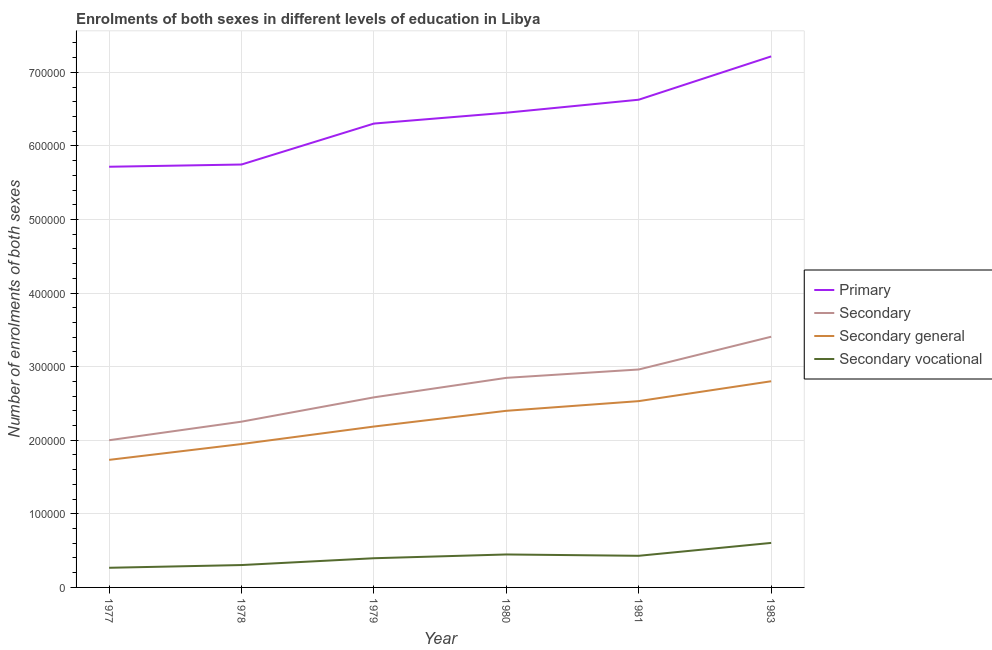Does the line corresponding to number of enrolments in secondary vocational education intersect with the line corresponding to number of enrolments in primary education?
Keep it short and to the point. No. What is the number of enrolments in primary education in 1978?
Provide a succinct answer. 5.75e+05. Across all years, what is the maximum number of enrolments in secondary vocational education?
Offer a terse response. 6.05e+04. Across all years, what is the minimum number of enrolments in primary education?
Provide a short and direct response. 5.72e+05. What is the total number of enrolments in secondary education in the graph?
Make the answer very short. 1.61e+06. What is the difference between the number of enrolments in secondary education in 1981 and that in 1983?
Give a very brief answer. -4.45e+04. What is the difference between the number of enrolments in secondary education in 1978 and the number of enrolments in primary education in 1977?
Provide a succinct answer. -3.46e+05. What is the average number of enrolments in secondary vocational education per year?
Your answer should be very brief. 4.08e+04. In the year 1977, what is the difference between the number of enrolments in secondary general education and number of enrolments in secondary vocational education?
Provide a short and direct response. 1.47e+05. What is the ratio of the number of enrolments in secondary vocational education in 1977 to that in 1981?
Your answer should be very brief. 0.62. What is the difference between the highest and the second highest number of enrolments in secondary general education?
Offer a very short reply. 2.70e+04. What is the difference between the highest and the lowest number of enrolments in secondary education?
Keep it short and to the point. 1.41e+05. Is the sum of the number of enrolments in secondary vocational education in 1978 and 1980 greater than the maximum number of enrolments in secondary general education across all years?
Provide a short and direct response. No. Does the number of enrolments in secondary general education monotonically increase over the years?
Offer a very short reply. Yes. Is the number of enrolments in secondary general education strictly greater than the number of enrolments in secondary education over the years?
Make the answer very short. No. Is the number of enrolments in secondary vocational education strictly less than the number of enrolments in secondary general education over the years?
Keep it short and to the point. Yes. How many lines are there?
Make the answer very short. 4. What is the difference between two consecutive major ticks on the Y-axis?
Your answer should be very brief. 1.00e+05. Does the graph contain grids?
Keep it short and to the point. Yes. Where does the legend appear in the graph?
Your answer should be compact. Center right. What is the title of the graph?
Offer a very short reply. Enrolments of both sexes in different levels of education in Libya. Does "Agriculture" appear as one of the legend labels in the graph?
Make the answer very short. No. What is the label or title of the Y-axis?
Make the answer very short. Number of enrolments of both sexes. What is the Number of enrolments of both sexes in Primary in 1977?
Give a very brief answer. 5.72e+05. What is the Number of enrolments of both sexes of Secondary in 1977?
Offer a terse response. 2.00e+05. What is the Number of enrolments of both sexes of Secondary general in 1977?
Your response must be concise. 1.73e+05. What is the Number of enrolments of both sexes of Secondary vocational in 1977?
Your answer should be very brief. 2.67e+04. What is the Number of enrolments of both sexes of Primary in 1978?
Your response must be concise. 5.75e+05. What is the Number of enrolments of both sexes of Secondary in 1978?
Your response must be concise. 2.25e+05. What is the Number of enrolments of both sexes of Secondary general in 1978?
Provide a succinct answer. 1.95e+05. What is the Number of enrolments of both sexes in Secondary vocational in 1978?
Your answer should be compact. 3.04e+04. What is the Number of enrolments of both sexes of Primary in 1979?
Your answer should be compact. 6.30e+05. What is the Number of enrolments of both sexes in Secondary in 1979?
Ensure brevity in your answer.  2.58e+05. What is the Number of enrolments of both sexes in Secondary general in 1979?
Give a very brief answer. 2.19e+05. What is the Number of enrolments of both sexes in Secondary vocational in 1979?
Offer a terse response. 3.97e+04. What is the Number of enrolments of both sexes in Primary in 1980?
Provide a short and direct response. 6.45e+05. What is the Number of enrolments of both sexes of Secondary in 1980?
Ensure brevity in your answer.  2.85e+05. What is the Number of enrolments of both sexes in Secondary general in 1980?
Provide a succinct answer. 2.40e+05. What is the Number of enrolments of both sexes in Secondary vocational in 1980?
Offer a very short reply. 4.48e+04. What is the Number of enrolments of both sexes in Primary in 1981?
Offer a very short reply. 6.63e+05. What is the Number of enrolments of both sexes in Secondary in 1981?
Offer a terse response. 2.96e+05. What is the Number of enrolments of both sexes in Secondary general in 1981?
Your answer should be compact. 2.53e+05. What is the Number of enrolments of both sexes in Secondary vocational in 1981?
Your answer should be compact. 4.30e+04. What is the Number of enrolments of both sexes of Primary in 1983?
Offer a very short reply. 7.22e+05. What is the Number of enrolments of both sexes in Secondary in 1983?
Your response must be concise. 3.41e+05. What is the Number of enrolments of both sexes in Secondary general in 1983?
Make the answer very short. 2.80e+05. What is the Number of enrolments of both sexes of Secondary vocational in 1983?
Ensure brevity in your answer.  6.05e+04. Across all years, what is the maximum Number of enrolments of both sexes of Primary?
Your answer should be compact. 7.22e+05. Across all years, what is the maximum Number of enrolments of both sexes in Secondary?
Keep it short and to the point. 3.41e+05. Across all years, what is the maximum Number of enrolments of both sexes of Secondary general?
Give a very brief answer. 2.80e+05. Across all years, what is the maximum Number of enrolments of both sexes in Secondary vocational?
Your answer should be very brief. 6.05e+04. Across all years, what is the minimum Number of enrolments of both sexes of Primary?
Keep it short and to the point. 5.72e+05. Across all years, what is the minimum Number of enrolments of both sexes in Secondary?
Your answer should be compact. 2.00e+05. Across all years, what is the minimum Number of enrolments of both sexes of Secondary general?
Keep it short and to the point. 1.73e+05. Across all years, what is the minimum Number of enrolments of both sexes in Secondary vocational?
Give a very brief answer. 2.67e+04. What is the total Number of enrolments of both sexes in Primary in the graph?
Offer a very short reply. 3.81e+06. What is the total Number of enrolments of both sexes of Secondary in the graph?
Your response must be concise. 1.61e+06. What is the total Number of enrolments of both sexes of Secondary general in the graph?
Offer a terse response. 1.36e+06. What is the total Number of enrolments of both sexes in Secondary vocational in the graph?
Offer a terse response. 2.45e+05. What is the difference between the Number of enrolments of both sexes of Primary in 1977 and that in 1978?
Make the answer very short. -3047. What is the difference between the Number of enrolments of both sexes in Secondary in 1977 and that in 1978?
Offer a very short reply. -2.52e+04. What is the difference between the Number of enrolments of both sexes of Secondary general in 1977 and that in 1978?
Ensure brevity in your answer.  -2.15e+04. What is the difference between the Number of enrolments of both sexes in Secondary vocational in 1977 and that in 1978?
Offer a terse response. -3711. What is the difference between the Number of enrolments of both sexes in Primary in 1977 and that in 1979?
Offer a terse response. -5.87e+04. What is the difference between the Number of enrolments of both sexes in Secondary in 1977 and that in 1979?
Keep it short and to the point. -5.83e+04. What is the difference between the Number of enrolments of both sexes of Secondary general in 1977 and that in 1979?
Provide a short and direct response. -4.53e+04. What is the difference between the Number of enrolments of both sexes of Secondary vocational in 1977 and that in 1979?
Offer a very short reply. -1.30e+04. What is the difference between the Number of enrolments of both sexes of Primary in 1977 and that in 1980?
Provide a succinct answer. -7.35e+04. What is the difference between the Number of enrolments of both sexes in Secondary in 1977 and that in 1980?
Provide a short and direct response. -8.48e+04. What is the difference between the Number of enrolments of both sexes in Secondary general in 1977 and that in 1980?
Your response must be concise. -6.67e+04. What is the difference between the Number of enrolments of both sexes of Secondary vocational in 1977 and that in 1980?
Your response must be concise. -1.81e+04. What is the difference between the Number of enrolments of both sexes in Primary in 1977 and that in 1981?
Give a very brief answer. -9.11e+04. What is the difference between the Number of enrolments of both sexes of Secondary in 1977 and that in 1981?
Give a very brief answer. -9.61e+04. What is the difference between the Number of enrolments of both sexes of Secondary general in 1977 and that in 1981?
Your answer should be compact. -7.98e+04. What is the difference between the Number of enrolments of both sexes in Secondary vocational in 1977 and that in 1981?
Keep it short and to the point. -1.63e+04. What is the difference between the Number of enrolments of both sexes of Primary in 1977 and that in 1983?
Keep it short and to the point. -1.50e+05. What is the difference between the Number of enrolments of both sexes of Secondary in 1977 and that in 1983?
Your answer should be compact. -1.41e+05. What is the difference between the Number of enrolments of both sexes in Secondary general in 1977 and that in 1983?
Offer a very short reply. -1.07e+05. What is the difference between the Number of enrolments of both sexes in Secondary vocational in 1977 and that in 1983?
Make the answer very short. -3.38e+04. What is the difference between the Number of enrolments of both sexes in Primary in 1978 and that in 1979?
Give a very brief answer. -5.57e+04. What is the difference between the Number of enrolments of both sexes in Secondary in 1978 and that in 1979?
Offer a very short reply. -3.31e+04. What is the difference between the Number of enrolments of both sexes of Secondary general in 1978 and that in 1979?
Offer a very short reply. -2.38e+04. What is the difference between the Number of enrolments of both sexes in Secondary vocational in 1978 and that in 1979?
Ensure brevity in your answer.  -9257. What is the difference between the Number of enrolments of both sexes in Primary in 1978 and that in 1980?
Your answer should be very brief. -7.04e+04. What is the difference between the Number of enrolments of both sexes of Secondary in 1978 and that in 1980?
Ensure brevity in your answer.  -5.95e+04. What is the difference between the Number of enrolments of both sexes in Secondary general in 1978 and that in 1980?
Your answer should be very brief. -4.52e+04. What is the difference between the Number of enrolments of both sexes in Secondary vocational in 1978 and that in 1980?
Make the answer very short. -1.44e+04. What is the difference between the Number of enrolments of both sexes of Primary in 1978 and that in 1981?
Give a very brief answer. -8.81e+04. What is the difference between the Number of enrolments of both sexes in Secondary in 1978 and that in 1981?
Your response must be concise. -7.09e+04. What is the difference between the Number of enrolments of both sexes in Secondary general in 1978 and that in 1981?
Give a very brief answer. -5.83e+04. What is the difference between the Number of enrolments of both sexes in Secondary vocational in 1978 and that in 1981?
Your response must be concise. -1.26e+04. What is the difference between the Number of enrolments of both sexes of Primary in 1978 and that in 1983?
Your answer should be very brief. -1.47e+05. What is the difference between the Number of enrolments of both sexes of Secondary in 1978 and that in 1983?
Your response must be concise. -1.15e+05. What is the difference between the Number of enrolments of both sexes of Secondary general in 1978 and that in 1983?
Give a very brief answer. -8.53e+04. What is the difference between the Number of enrolments of both sexes in Secondary vocational in 1978 and that in 1983?
Your answer should be very brief. -3.01e+04. What is the difference between the Number of enrolments of both sexes in Primary in 1979 and that in 1980?
Ensure brevity in your answer.  -1.48e+04. What is the difference between the Number of enrolments of both sexes in Secondary in 1979 and that in 1980?
Ensure brevity in your answer.  -2.65e+04. What is the difference between the Number of enrolments of both sexes of Secondary general in 1979 and that in 1980?
Make the answer very short. -2.14e+04. What is the difference between the Number of enrolments of both sexes of Secondary vocational in 1979 and that in 1980?
Make the answer very short. -5113. What is the difference between the Number of enrolments of both sexes in Primary in 1979 and that in 1981?
Provide a short and direct response. -3.24e+04. What is the difference between the Number of enrolments of both sexes in Secondary in 1979 and that in 1981?
Offer a terse response. -3.79e+04. What is the difference between the Number of enrolments of both sexes of Secondary general in 1979 and that in 1981?
Provide a succinct answer. -3.45e+04. What is the difference between the Number of enrolments of both sexes of Secondary vocational in 1979 and that in 1981?
Your response must be concise. -3319. What is the difference between the Number of enrolments of both sexes of Primary in 1979 and that in 1983?
Keep it short and to the point. -9.13e+04. What is the difference between the Number of enrolments of both sexes in Secondary in 1979 and that in 1983?
Ensure brevity in your answer.  -8.24e+04. What is the difference between the Number of enrolments of both sexes in Secondary general in 1979 and that in 1983?
Ensure brevity in your answer.  -6.15e+04. What is the difference between the Number of enrolments of both sexes of Secondary vocational in 1979 and that in 1983?
Your answer should be compact. -2.08e+04. What is the difference between the Number of enrolments of both sexes in Primary in 1980 and that in 1981?
Provide a short and direct response. -1.77e+04. What is the difference between the Number of enrolments of both sexes in Secondary in 1980 and that in 1981?
Keep it short and to the point. -1.14e+04. What is the difference between the Number of enrolments of both sexes in Secondary general in 1980 and that in 1981?
Your answer should be very brief. -1.32e+04. What is the difference between the Number of enrolments of both sexes of Secondary vocational in 1980 and that in 1981?
Offer a very short reply. 1794. What is the difference between the Number of enrolments of both sexes of Primary in 1980 and that in 1983?
Your answer should be very brief. -7.65e+04. What is the difference between the Number of enrolments of both sexes of Secondary in 1980 and that in 1983?
Provide a short and direct response. -5.59e+04. What is the difference between the Number of enrolments of both sexes of Secondary general in 1980 and that in 1983?
Offer a terse response. -4.02e+04. What is the difference between the Number of enrolments of both sexes of Secondary vocational in 1980 and that in 1983?
Provide a succinct answer. -1.57e+04. What is the difference between the Number of enrolments of both sexes of Primary in 1981 and that in 1983?
Ensure brevity in your answer.  -5.89e+04. What is the difference between the Number of enrolments of both sexes in Secondary in 1981 and that in 1983?
Provide a succinct answer. -4.45e+04. What is the difference between the Number of enrolments of both sexes of Secondary general in 1981 and that in 1983?
Ensure brevity in your answer.  -2.70e+04. What is the difference between the Number of enrolments of both sexes of Secondary vocational in 1981 and that in 1983?
Your answer should be very brief. -1.75e+04. What is the difference between the Number of enrolments of both sexes of Primary in 1977 and the Number of enrolments of both sexes of Secondary in 1978?
Ensure brevity in your answer.  3.46e+05. What is the difference between the Number of enrolments of both sexes of Primary in 1977 and the Number of enrolments of both sexes of Secondary general in 1978?
Your answer should be very brief. 3.77e+05. What is the difference between the Number of enrolments of both sexes in Primary in 1977 and the Number of enrolments of both sexes in Secondary vocational in 1978?
Offer a terse response. 5.41e+05. What is the difference between the Number of enrolments of both sexes of Secondary in 1977 and the Number of enrolments of both sexes of Secondary general in 1978?
Your response must be concise. 5197. What is the difference between the Number of enrolments of both sexes of Secondary in 1977 and the Number of enrolments of both sexes of Secondary vocational in 1978?
Make the answer very short. 1.70e+05. What is the difference between the Number of enrolments of both sexes of Secondary general in 1977 and the Number of enrolments of both sexes of Secondary vocational in 1978?
Provide a succinct answer. 1.43e+05. What is the difference between the Number of enrolments of both sexes of Primary in 1977 and the Number of enrolments of both sexes of Secondary in 1979?
Offer a terse response. 3.13e+05. What is the difference between the Number of enrolments of both sexes in Primary in 1977 and the Number of enrolments of both sexes in Secondary general in 1979?
Your answer should be very brief. 3.53e+05. What is the difference between the Number of enrolments of both sexes in Primary in 1977 and the Number of enrolments of both sexes in Secondary vocational in 1979?
Provide a short and direct response. 5.32e+05. What is the difference between the Number of enrolments of both sexes in Secondary in 1977 and the Number of enrolments of both sexes in Secondary general in 1979?
Your answer should be very brief. -1.86e+04. What is the difference between the Number of enrolments of both sexes of Secondary in 1977 and the Number of enrolments of both sexes of Secondary vocational in 1979?
Your answer should be very brief. 1.60e+05. What is the difference between the Number of enrolments of both sexes in Secondary general in 1977 and the Number of enrolments of both sexes in Secondary vocational in 1979?
Make the answer very short. 1.34e+05. What is the difference between the Number of enrolments of both sexes in Primary in 1977 and the Number of enrolments of both sexes in Secondary in 1980?
Ensure brevity in your answer.  2.87e+05. What is the difference between the Number of enrolments of both sexes in Primary in 1977 and the Number of enrolments of both sexes in Secondary general in 1980?
Your answer should be very brief. 3.32e+05. What is the difference between the Number of enrolments of both sexes in Primary in 1977 and the Number of enrolments of both sexes in Secondary vocational in 1980?
Make the answer very short. 5.27e+05. What is the difference between the Number of enrolments of both sexes in Secondary in 1977 and the Number of enrolments of both sexes in Secondary general in 1980?
Make the answer very short. -4.00e+04. What is the difference between the Number of enrolments of both sexes in Secondary in 1977 and the Number of enrolments of both sexes in Secondary vocational in 1980?
Your answer should be compact. 1.55e+05. What is the difference between the Number of enrolments of both sexes of Secondary general in 1977 and the Number of enrolments of both sexes of Secondary vocational in 1980?
Ensure brevity in your answer.  1.29e+05. What is the difference between the Number of enrolments of both sexes in Primary in 1977 and the Number of enrolments of both sexes in Secondary in 1981?
Ensure brevity in your answer.  2.76e+05. What is the difference between the Number of enrolments of both sexes in Primary in 1977 and the Number of enrolments of both sexes in Secondary general in 1981?
Make the answer very short. 3.19e+05. What is the difference between the Number of enrolments of both sexes of Primary in 1977 and the Number of enrolments of both sexes of Secondary vocational in 1981?
Your answer should be very brief. 5.29e+05. What is the difference between the Number of enrolments of both sexes in Secondary in 1977 and the Number of enrolments of both sexes in Secondary general in 1981?
Your answer should be compact. -5.31e+04. What is the difference between the Number of enrolments of both sexes of Secondary in 1977 and the Number of enrolments of both sexes of Secondary vocational in 1981?
Your response must be concise. 1.57e+05. What is the difference between the Number of enrolments of both sexes in Secondary general in 1977 and the Number of enrolments of both sexes in Secondary vocational in 1981?
Your response must be concise. 1.30e+05. What is the difference between the Number of enrolments of both sexes of Primary in 1977 and the Number of enrolments of both sexes of Secondary in 1983?
Keep it short and to the point. 2.31e+05. What is the difference between the Number of enrolments of both sexes of Primary in 1977 and the Number of enrolments of both sexes of Secondary general in 1983?
Provide a succinct answer. 2.92e+05. What is the difference between the Number of enrolments of both sexes of Primary in 1977 and the Number of enrolments of both sexes of Secondary vocational in 1983?
Keep it short and to the point. 5.11e+05. What is the difference between the Number of enrolments of both sexes in Secondary in 1977 and the Number of enrolments of both sexes in Secondary general in 1983?
Your answer should be compact. -8.01e+04. What is the difference between the Number of enrolments of both sexes of Secondary in 1977 and the Number of enrolments of both sexes of Secondary vocational in 1983?
Offer a terse response. 1.40e+05. What is the difference between the Number of enrolments of both sexes of Secondary general in 1977 and the Number of enrolments of both sexes of Secondary vocational in 1983?
Your answer should be compact. 1.13e+05. What is the difference between the Number of enrolments of both sexes in Primary in 1978 and the Number of enrolments of both sexes in Secondary in 1979?
Ensure brevity in your answer.  3.16e+05. What is the difference between the Number of enrolments of both sexes of Primary in 1978 and the Number of enrolments of both sexes of Secondary general in 1979?
Give a very brief answer. 3.56e+05. What is the difference between the Number of enrolments of both sexes in Primary in 1978 and the Number of enrolments of both sexes in Secondary vocational in 1979?
Your response must be concise. 5.35e+05. What is the difference between the Number of enrolments of both sexes in Secondary in 1978 and the Number of enrolments of both sexes in Secondary general in 1979?
Your answer should be compact. 6620. What is the difference between the Number of enrolments of both sexes in Secondary in 1978 and the Number of enrolments of both sexes in Secondary vocational in 1979?
Offer a very short reply. 1.86e+05. What is the difference between the Number of enrolments of both sexes in Secondary general in 1978 and the Number of enrolments of both sexes in Secondary vocational in 1979?
Your response must be concise. 1.55e+05. What is the difference between the Number of enrolments of both sexes in Primary in 1978 and the Number of enrolments of both sexes in Secondary in 1980?
Your answer should be very brief. 2.90e+05. What is the difference between the Number of enrolments of both sexes of Primary in 1978 and the Number of enrolments of both sexes of Secondary general in 1980?
Offer a terse response. 3.35e+05. What is the difference between the Number of enrolments of both sexes in Primary in 1978 and the Number of enrolments of both sexes in Secondary vocational in 1980?
Give a very brief answer. 5.30e+05. What is the difference between the Number of enrolments of both sexes in Secondary in 1978 and the Number of enrolments of both sexes in Secondary general in 1980?
Provide a short and direct response. -1.48e+04. What is the difference between the Number of enrolments of both sexes in Secondary in 1978 and the Number of enrolments of both sexes in Secondary vocational in 1980?
Give a very brief answer. 1.80e+05. What is the difference between the Number of enrolments of both sexes of Secondary general in 1978 and the Number of enrolments of both sexes of Secondary vocational in 1980?
Offer a terse response. 1.50e+05. What is the difference between the Number of enrolments of both sexes in Primary in 1978 and the Number of enrolments of both sexes in Secondary in 1981?
Make the answer very short. 2.79e+05. What is the difference between the Number of enrolments of both sexes of Primary in 1978 and the Number of enrolments of both sexes of Secondary general in 1981?
Give a very brief answer. 3.22e+05. What is the difference between the Number of enrolments of both sexes of Primary in 1978 and the Number of enrolments of both sexes of Secondary vocational in 1981?
Provide a succinct answer. 5.32e+05. What is the difference between the Number of enrolments of both sexes in Secondary in 1978 and the Number of enrolments of both sexes in Secondary general in 1981?
Ensure brevity in your answer.  -2.79e+04. What is the difference between the Number of enrolments of both sexes of Secondary in 1978 and the Number of enrolments of both sexes of Secondary vocational in 1981?
Keep it short and to the point. 1.82e+05. What is the difference between the Number of enrolments of both sexes in Secondary general in 1978 and the Number of enrolments of both sexes in Secondary vocational in 1981?
Keep it short and to the point. 1.52e+05. What is the difference between the Number of enrolments of both sexes of Primary in 1978 and the Number of enrolments of both sexes of Secondary in 1983?
Your answer should be very brief. 2.34e+05. What is the difference between the Number of enrolments of both sexes of Primary in 1978 and the Number of enrolments of both sexes of Secondary general in 1983?
Keep it short and to the point. 2.95e+05. What is the difference between the Number of enrolments of both sexes in Primary in 1978 and the Number of enrolments of both sexes in Secondary vocational in 1983?
Ensure brevity in your answer.  5.14e+05. What is the difference between the Number of enrolments of both sexes in Secondary in 1978 and the Number of enrolments of both sexes in Secondary general in 1983?
Offer a terse response. -5.49e+04. What is the difference between the Number of enrolments of both sexes in Secondary in 1978 and the Number of enrolments of both sexes in Secondary vocational in 1983?
Provide a short and direct response. 1.65e+05. What is the difference between the Number of enrolments of both sexes in Secondary general in 1978 and the Number of enrolments of both sexes in Secondary vocational in 1983?
Your response must be concise. 1.34e+05. What is the difference between the Number of enrolments of both sexes in Primary in 1979 and the Number of enrolments of both sexes in Secondary in 1980?
Make the answer very short. 3.46e+05. What is the difference between the Number of enrolments of both sexes of Primary in 1979 and the Number of enrolments of both sexes of Secondary general in 1980?
Provide a succinct answer. 3.90e+05. What is the difference between the Number of enrolments of both sexes of Primary in 1979 and the Number of enrolments of both sexes of Secondary vocational in 1980?
Ensure brevity in your answer.  5.86e+05. What is the difference between the Number of enrolments of both sexes in Secondary in 1979 and the Number of enrolments of both sexes in Secondary general in 1980?
Your answer should be compact. 1.83e+04. What is the difference between the Number of enrolments of both sexes of Secondary in 1979 and the Number of enrolments of both sexes of Secondary vocational in 1980?
Provide a succinct answer. 2.14e+05. What is the difference between the Number of enrolments of both sexes of Secondary general in 1979 and the Number of enrolments of both sexes of Secondary vocational in 1980?
Offer a very short reply. 1.74e+05. What is the difference between the Number of enrolments of both sexes of Primary in 1979 and the Number of enrolments of both sexes of Secondary in 1981?
Provide a short and direct response. 3.34e+05. What is the difference between the Number of enrolments of both sexes in Primary in 1979 and the Number of enrolments of both sexes in Secondary general in 1981?
Offer a terse response. 3.77e+05. What is the difference between the Number of enrolments of both sexes of Primary in 1979 and the Number of enrolments of both sexes of Secondary vocational in 1981?
Keep it short and to the point. 5.87e+05. What is the difference between the Number of enrolments of both sexes in Secondary in 1979 and the Number of enrolments of both sexes in Secondary general in 1981?
Give a very brief answer. 5142. What is the difference between the Number of enrolments of both sexes in Secondary in 1979 and the Number of enrolments of both sexes in Secondary vocational in 1981?
Ensure brevity in your answer.  2.15e+05. What is the difference between the Number of enrolments of both sexes in Secondary general in 1979 and the Number of enrolments of both sexes in Secondary vocational in 1981?
Offer a terse response. 1.76e+05. What is the difference between the Number of enrolments of both sexes in Primary in 1979 and the Number of enrolments of both sexes in Secondary in 1983?
Provide a succinct answer. 2.90e+05. What is the difference between the Number of enrolments of both sexes in Primary in 1979 and the Number of enrolments of both sexes in Secondary general in 1983?
Keep it short and to the point. 3.50e+05. What is the difference between the Number of enrolments of both sexes in Primary in 1979 and the Number of enrolments of both sexes in Secondary vocational in 1983?
Provide a short and direct response. 5.70e+05. What is the difference between the Number of enrolments of both sexes in Secondary in 1979 and the Number of enrolments of both sexes in Secondary general in 1983?
Give a very brief answer. -2.19e+04. What is the difference between the Number of enrolments of both sexes of Secondary in 1979 and the Number of enrolments of both sexes of Secondary vocational in 1983?
Make the answer very short. 1.98e+05. What is the difference between the Number of enrolments of both sexes of Secondary general in 1979 and the Number of enrolments of both sexes of Secondary vocational in 1983?
Provide a short and direct response. 1.58e+05. What is the difference between the Number of enrolments of both sexes of Primary in 1980 and the Number of enrolments of both sexes of Secondary in 1981?
Offer a terse response. 3.49e+05. What is the difference between the Number of enrolments of both sexes of Primary in 1980 and the Number of enrolments of both sexes of Secondary general in 1981?
Provide a short and direct response. 3.92e+05. What is the difference between the Number of enrolments of both sexes of Primary in 1980 and the Number of enrolments of both sexes of Secondary vocational in 1981?
Your answer should be compact. 6.02e+05. What is the difference between the Number of enrolments of both sexes in Secondary in 1980 and the Number of enrolments of both sexes in Secondary general in 1981?
Offer a terse response. 3.16e+04. What is the difference between the Number of enrolments of both sexes in Secondary in 1980 and the Number of enrolments of both sexes in Secondary vocational in 1981?
Provide a succinct answer. 2.42e+05. What is the difference between the Number of enrolments of both sexes in Secondary general in 1980 and the Number of enrolments of both sexes in Secondary vocational in 1981?
Offer a very short reply. 1.97e+05. What is the difference between the Number of enrolments of both sexes of Primary in 1980 and the Number of enrolments of both sexes of Secondary in 1983?
Your answer should be very brief. 3.04e+05. What is the difference between the Number of enrolments of both sexes in Primary in 1980 and the Number of enrolments of both sexes in Secondary general in 1983?
Make the answer very short. 3.65e+05. What is the difference between the Number of enrolments of both sexes of Primary in 1980 and the Number of enrolments of both sexes of Secondary vocational in 1983?
Provide a short and direct response. 5.85e+05. What is the difference between the Number of enrolments of both sexes in Secondary in 1980 and the Number of enrolments of both sexes in Secondary general in 1983?
Your answer should be very brief. 4618. What is the difference between the Number of enrolments of both sexes of Secondary in 1980 and the Number of enrolments of both sexes of Secondary vocational in 1983?
Your response must be concise. 2.24e+05. What is the difference between the Number of enrolments of both sexes of Secondary general in 1980 and the Number of enrolments of both sexes of Secondary vocational in 1983?
Ensure brevity in your answer.  1.80e+05. What is the difference between the Number of enrolments of both sexes in Primary in 1981 and the Number of enrolments of both sexes in Secondary in 1983?
Make the answer very short. 3.22e+05. What is the difference between the Number of enrolments of both sexes in Primary in 1981 and the Number of enrolments of both sexes in Secondary general in 1983?
Keep it short and to the point. 3.83e+05. What is the difference between the Number of enrolments of both sexes in Primary in 1981 and the Number of enrolments of both sexes in Secondary vocational in 1983?
Offer a terse response. 6.02e+05. What is the difference between the Number of enrolments of both sexes in Secondary in 1981 and the Number of enrolments of both sexes in Secondary general in 1983?
Your answer should be compact. 1.60e+04. What is the difference between the Number of enrolments of both sexes of Secondary in 1981 and the Number of enrolments of both sexes of Secondary vocational in 1983?
Your response must be concise. 2.36e+05. What is the difference between the Number of enrolments of both sexes of Secondary general in 1981 and the Number of enrolments of both sexes of Secondary vocational in 1983?
Your response must be concise. 1.93e+05. What is the average Number of enrolments of both sexes of Primary per year?
Offer a terse response. 6.34e+05. What is the average Number of enrolments of both sexes in Secondary per year?
Provide a short and direct response. 2.68e+05. What is the average Number of enrolments of both sexes in Secondary general per year?
Give a very brief answer. 2.27e+05. What is the average Number of enrolments of both sexes in Secondary vocational per year?
Keep it short and to the point. 4.08e+04. In the year 1977, what is the difference between the Number of enrolments of both sexes in Primary and Number of enrolments of both sexes in Secondary?
Offer a very short reply. 3.72e+05. In the year 1977, what is the difference between the Number of enrolments of both sexes of Primary and Number of enrolments of both sexes of Secondary general?
Your response must be concise. 3.98e+05. In the year 1977, what is the difference between the Number of enrolments of both sexes in Primary and Number of enrolments of both sexes in Secondary vocational?
Ensure brevity in your answer.  5.45e+05. In the year 1977, what is the difference between the Number of enrolments of both sexes of Secondary and Number of enrolments of both sexes of Secondary general?
Provide a short and direct response. 2.67e+04. In the year 1977, what is the difference between the Number of enrolments of both sexes of Secondary and Number of enrolments of both sexes of Secondary vocational?
Provide a succinct answer. 1.73e+05. In the year 1977, what is the difference between the Number of enrolments of both sexes of Secondary general and Number of enrolments of both sexes of Secondary vocational?
Keep it short and to the point. 1.47e+05. In the year 1978, what is the difference between the Number of enrolments of both sexes in Primary and Number of enrolments of both sexes in Secondary?
Offer a very short reply. 3.49e+05. In the year 1978, what is the difference between the Number of enrolments of both sexes of Primary and Number of enrolments of both sexes of Secondary general?
Provide a succinct answer. 3.80e+05. In the year 1978, what is the difference between the Number of enrolments of both sexes in Primary and Number of enrolments of both sexes in Secondary vocational?
Your response must be concise. 5.44e+05. In the year 1978, what is the difference between the Number of enrolments of both sexes of Secondary and Number of enrolments of both sexes of Secondary general?
Your response must be concise. 3.04e+04. In the year 1978, what is the difference between the Number of enrolments of both sexes in Secondary and Number of enrolments of both sexes in Secondary vocational?
Offer a very short reply. 1.95e+05. In the year 1978, what is the difference between the Number of enrolments of both sexes of Secondary general and Number of enrolments of both sexes of Secondary vocational?
Offer a terse response. 1.64e+05. In the year 1979, what is the difference between the Number of enrolments of both sexes of Primary and Number of enrolments of both sexes of Secondary?
Your answer should be compact. 3.72e+05. In the year 1979, what is the difference between the Number of enrolments of both sexes of Primary and Number of enrolments of both sexes of Secondary general?
Your answer should be very brief. 4.12e+05. In the year 1979, what is the difference between the Number of enrolments of both sexes in Primary and Number of enrolments of both sexes in Secondary vocational?
Provide a succinct answer. 5.91e+05. In the year 1979, what is the difference between the Number of enrolments of both sexes in Secondary and Number of enrolments of both sexes in Secondary general?
Offer a terse response. 3.97e+04. In the year 1979, what is the difference between the Number of enrolments of both sexes of Secondary and Number of enrolments of both sexes of Secondary vocational?
Ensure brevity in your answer.  2.19e+05. In the year 1979, what is the difference between the Number of enrolments of both sexes in Secondary general and Number of enrolments of both sexes in Secondary vocational?
Your response must be concise. 1.79e+05. In the year 1980, what is the difference between the Number of enrolments of both sexes in Primary and Number of enrolments of both sexes in Secondary?
Provide a succinct answer. 3.60e+05. In the year 1980, what is the difference between the Number of enrolments of both sexes of Primary and Number of enrolments of both sexes of Secondary general?
Keep it short and to the point. 4.05e+05. In the year 1980, what is the difference between the Number of enrolments of both sexes of Primary and Number of enrolments of both sexes of Secondary vocational?
Give a very brief answer. 6.00e+05. In the year 1980, what is the difference between the Number of enrolments of both sexes in Secondary and Number of enrolments of both sexes in Secondary general?
Provide a succinct answer. 4.48e+04. In the year 1980, what is the difference between the Number of enrolments of both sexes of Secondary and Number of enrolments of both sexes of Secondary vocational?
Offer a very short reply. 2.40e+05. In the year 1980, what is the difference between the Number of enrolments of both sexes of Secondary general and Number of enrolments of both sexes of Secondary vocational?
Make the answer very short. 1.95e+05. In the year 1981, what is the difference between the Number of enrolments of both sexes of Primary and Number of enrolments of both sexes of Secondary?
Provide a short and direct response. 3.67e+05. In the year 1981, what is the difference between the Number of enrolments of both sexes in Primary and Number of enrolments of both sexes in Secondary general?
Your response must be concise. 4.10e+05. In the year 1981, what is the difference between the Number of enrolments of both sexes in Primary and Number of enrolments of both sexes in Secondary vocational?
Make the answer very short. 6.20e+05. In the year 1981, what is the difference between the Number of enrolments of both sexes of Secondary and Number of enrolments of both sexes of Secondary general?
Give a very brief answer. 4.30e+04. In the year 1981, what is the difference between the Number of enrolments of both sexes in Secondary and Number of enrolments of both sexes in Secondary vocational?
Your answer should be compact. 2.53e+05. In the year 1981, what is the difference between the Number of enrolments of both sexes of Secondary general and Number of enrolments of both sexes of Secondary vocational?
Your response must be concise. 2.10e+05. In the year 1983, what is the difference between the Number of enrolments of both sexes in Primary and Number of enrolments of both sexes in Secondary?
Ensure brevity in your answer.  3.81e+05. In the year 1983, what is the difference between the Number of enrolments of both sexes of Primary and Number of enrolments of both sexes of Secondary general?
Ensure brevity in your answer.  4.42e+05. In the year 1983, what is the difference between the Number of enrolments of both sexes of Primary and Number of enrolments of both sexes of Secondary vocational?
Provide a succinct answer. 6.61e+05. In the year 1983, what is the difference between the Number of enrolments of both sexes of Secondary and Number of enrolments of both sexes of Secondary general?
Make the answer very short. 6.05e+04. In the year 1983, what is the difference between the Number of enrolments of both sexes in Secondary and Number of enrolments of both sexes in Secondary vocational?
Provide a succinct answer. 2.80e+05. In the year 1983, what is the difference between the Number of enrolments of both sexes in Secondary general and Number of enrolments of both sexes in Secondary vocational?
Keep it short and to the point. 2.20e+05. What is the ratio of the Number of enrolments of both sexes in Secondary in 1977 to that in 1978?
Provide a short and direct response. 0.89. What is the ratio of the Number of enrolments of both sexes of Secondary general in 1977 to that in 1978?
Your response must be concise. 0.89. What is the ratio of the Number of enrolments of both sexes in Secondary vocational in 1977 to that in 1978?
Keep it short and to the point. 0.88. What is the ratio of the Number of enrolments of both sexes in Primary in 1977 to that in 1979?
Offer a very short reply. 0.91. What is the ratio of the Number of enrolments of both sexes in Secondary in 1977 to that in 1979?
Keep it short and to the point. 0.77. What is the ratio of the Number of enrolments of both sexes in Secondary general in 1977 to that in 1979?
Make the answer very short. 0.79. What is the ratio of the Number of enrolments of both sexes of Secondary vocational in 1977 to that in 1979?
Your answer should be very brief. 0.67. What is the ratio of the Number of enrolments of both sexes of Primary in 1977 to that in 1980?
Ensure brevity in your answer.  0.89. What is the ratio of the Number of enrolments of both sexes in Secondary in 1977 to that in 1980?
Provide a short and direct response. 0.7. What is the ratio of the Number of enrolments of both sexes in Secondary general in 1977 to that in 1980?
Keep it short and to the point. 0.72. What is the ratio of the Number of enrolments of both sexes of Secondary vocational in 1977 to that in 1980?
Keep it short and to the point. 0.6. What is the ratio of the Number of enrolments of both sexes in Primary in 1977 to that in 1981?
Your answer should be very brief. 0.86. What is the ratio of the Number of enrolments of both sexes in Secondary in 1977 to that in 1981?
Make the answer very short. 0.68. What is the ratio of the Number of enrolments of both sexes of Secondary general in 1977 to that in 1981?
Ensure brevity in your answer.  0.68. What is the ratio of the Number of enrolments of both sexes in Secondary vocational in 1977 to that in 1981?
Provide a short and direct response. 0.62. What is the ratio of the Number of enrolments of both sexes in Primary in 1977 to that in 1983?
Your answer should be very brief. 0.79. What is the ratio of the Number of enrolments of both sexes in Secondary in 1977 to that in 1983?
Offer a very short reply. 0.59. What is the ratio of the Number of enrolments of both sexes of Secondary general in 1977 to that in 1983?
Provide a short and direct response. 0.62. What is the ratio of the Number of enrolments of both sexes in Secondary vocational in 1977 to that in 1983?
Ensure brevity in your answer.  0.44. What is the ratio of the Number of enrolments of both sexes in Primary in 1978 to that in 1979?
Provide a short and direct response. 0.91. What is the ratio of the Number of enrolments of both sexes in Secondary in 1978 to that in 1979?
Ensure brevity in your answer.  0.87. What is the ratio of the Number of enrolments of both sexes in Secondary general in 1978 to that in 1979?
Your answer should be very brief. 0.89. What is the ratio of the Number of enrolments of both sexes of Secondary vocational in 1978 to that in 1979?
Your answer should be compact. 0.77. What is the ratio of the Number of enrolments of both sexes in Primary in 1978 to that in 1980?
Make the answer very short. 0.89. What is the ratio of the Number of enrolments of both sexes in Secondary in 1978 to that in 1980?
Provide a short and direct response. 0.79. What is the ratio of the Number of enrolments of both sexes of Secondary general in 1978 to that in 1980?
Offer a very short reply. 0.81. What is the ratio of the Number of enrolments of both sexes in Secondary vocational in 1978 to that in 1980?
Offer a very short reply. 0.68. What is the ratio of the Number of enrolments of both sexes of Primary in 1978 to that in 1981?
Your response must be concise. 0.87. What is the ratio of the Number of enrolments of both sexes of Secondary in 1978 to that in 1981?
Your answer should be very brief. 0.76. What is the ratio of the Number of enrolments of both sexes of Secondary general in 1978 to that in 1981?
Give a very brief answer. 0.77. What is the ratio of the Number of enrolments of both sexes of Secondary vocational in 1978 to that in 1981?
Give a very brief answer. 0.71. What is the ratio of the Number of enrolments of both sexes in Primary in 1978 to that in 1983?
Ensure brevity in your answer.  0.8. What is the ratio of the Number of enrolments of both sexes of Secondary in 1978 to that in 1983?
Keep it short and to the point. 0.66. What is the ratio of the Number of enrolments of both sexes in Secondary general in 1978 to that in 1983?
Ensure brevity in your answer.  0.7. What is the ratio of the Number of enrolments of both sexes of Secondary vocational in 1978 to that in 1983?
Provide a succinct answer. 0.5. What is the ratio of the Number of enrolments of both sexes of Primary in 1979 to that in 1980?
Provide a succinct answer. 0.98. What is the ratio of the Number of enrolments of both sexes in Secondary in 1979 to that in 1980?
Keep it short and to the point. 0.91. What is the ratio of the Number of enrolments of both sexes in Secondary general in 1979 to that in 1980?
Ensure brevity in your answer.  0.91. What is the ratio of the Number of enrolments of both sexes of Secondary vocational in 1979 to that in 1980?
Make the answer very short. 0.89. What is the ratio of the Number of enrolments of both sexes in Primary in 1979 to that in 1981?
Offer a very short reply. 0.95. What is the ratio of the Number of enrolments of both sexes of Secondary in 1979 to that in 1981?
Keep it short and to the point. 0.87. What is the ratio of the Number of enrolments of both sexes in Secondary general in 1979 to that in 1981?
Provide a short and direct response. 0.86. What is the ratio of the Number of enrolments of both sexes in Secondary vocational in 1979 to that in 1981?
Ensure brevity in your answer.  0.92. What is the ratio of the Number of enrolments of both sexes of Primary in 1979 to that in 1983?
Provide a short and direct response. 0.87. What is the ratio of the Number of enrolments of both sexes in Secondary in 1979 to that in 1983?
Make the answer very short. 0.76. What is the ratio of the Number of enrolments of both sexes in Secondary general in 1979 to that in 1983?
Make the answer very short. 0.78. What is the ratio of the Number of enrolments of both sexes of Secondary vocational in 1979 to that in 1983?
Provide a succinct answer. 0.66. What is the ratio of the Number of enrolments of both sexes of Primary in 1980 to that in 1981?
Your answer should be very brief. 0.97. What is the ratio of the Number of enrolments of both sexes in Secondary in 1980 to that in 1981?
Ensure brevity in your answer.  0.96. What is the ratio of the Number of enrolments of both sexes of Secondary general in 1980 to that in 1981?
Provide a short and direct response. 0.95. What is the ratio of the Number of enrolments of both sexes of Secondary vocational in 1980 to that in 1981?
Offer a terse response. 1.04. What is the ratio of the Number of enrolments of both sexes in Primary in 1980 to that in 1983?
Keep it short and to the point. 0.89. What is the ratio of the Number of enrolments of both sexes in Secondary in 1980 to that in 1983?
Provide a short and direct response. 0.84. What is the ratio of the Number of enrolments of both sexes in Secondary general in 1980 to that in 1983?
Give a very brief answer. 0.86. What is the ratio of the Number of enrolments of both sexes of Secondary vocational in 1980 to that in 1983?
Keep it short and to the point. 0.74. What is the ratio of the Number of enrolments of both sexes of Primary in 1981 to that in 1983?
Your answer should be very brief. 0.92. What is the ratio of the Number of enrolments of both sexes in Secondary in 1981 to that in 1983?
Your response must be concise. 0.87. What is the ratio of the Number of enrolments of both sexes in Secondary general in 1981 to that in 1983?
Keep it short and to the point. 0.9. What is the ratio of the Number of enrolments of both sexes in Secondary vocational in 1981 to that in 1983?
Give a very brief answer. 0.71. What is the difference between the highest and the second highest Number of enrolments of both sexes of Primary?
Your answer should be very brief. 5.89e+04. What is the difference between the highest and the second highest Number of enrolments of both sexes of Secondary?
Give a very brief answer. 4.45e+04. What is the difference between the highest and the second highest Number of enrolments of both sexes of Secondary general?
Your response must be concise. 2.70e+04. What is the difference between the highest and the second highest Number of enrolments of both sexes of Secondary vocational?
Make the answer very short. 1.57e+04. What is the difference between the highest and the lowest Number of enrolments of both sexes in Primary?
Offer a terse response. 1.50e+05. What is the difference between the highest and the lowest Number of enrolments of both sexes of Secondary?
Your answer should be very brief. 1.41e+05. What is the difference between the highest and the lowest Number of enrolments of both sexes in Secondary general?
Offer a terse response. 1.07e+05. What is the difference between the highest and the lowest Number of enrolments of both sexes of Secondary vocational?
Give a very brief answer. 3.38e+04. 